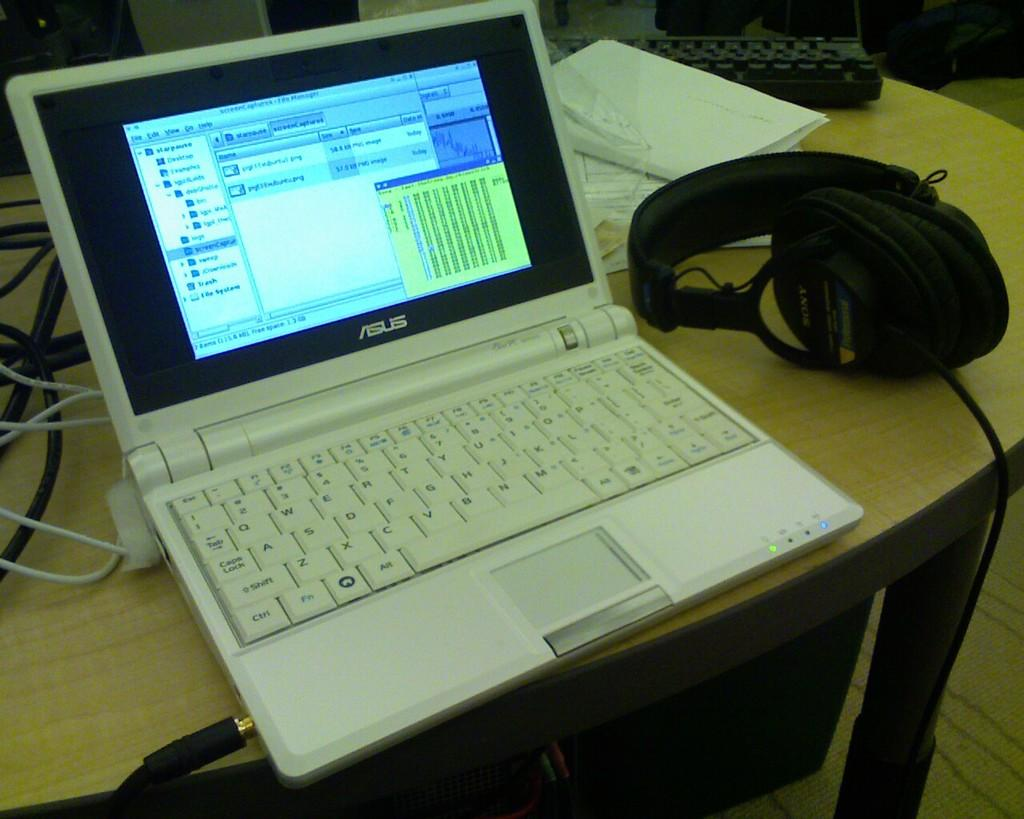<image>
Render a clear and concise summary of the photo. An open white Asus laptop sitting next to a pair of headphones. 